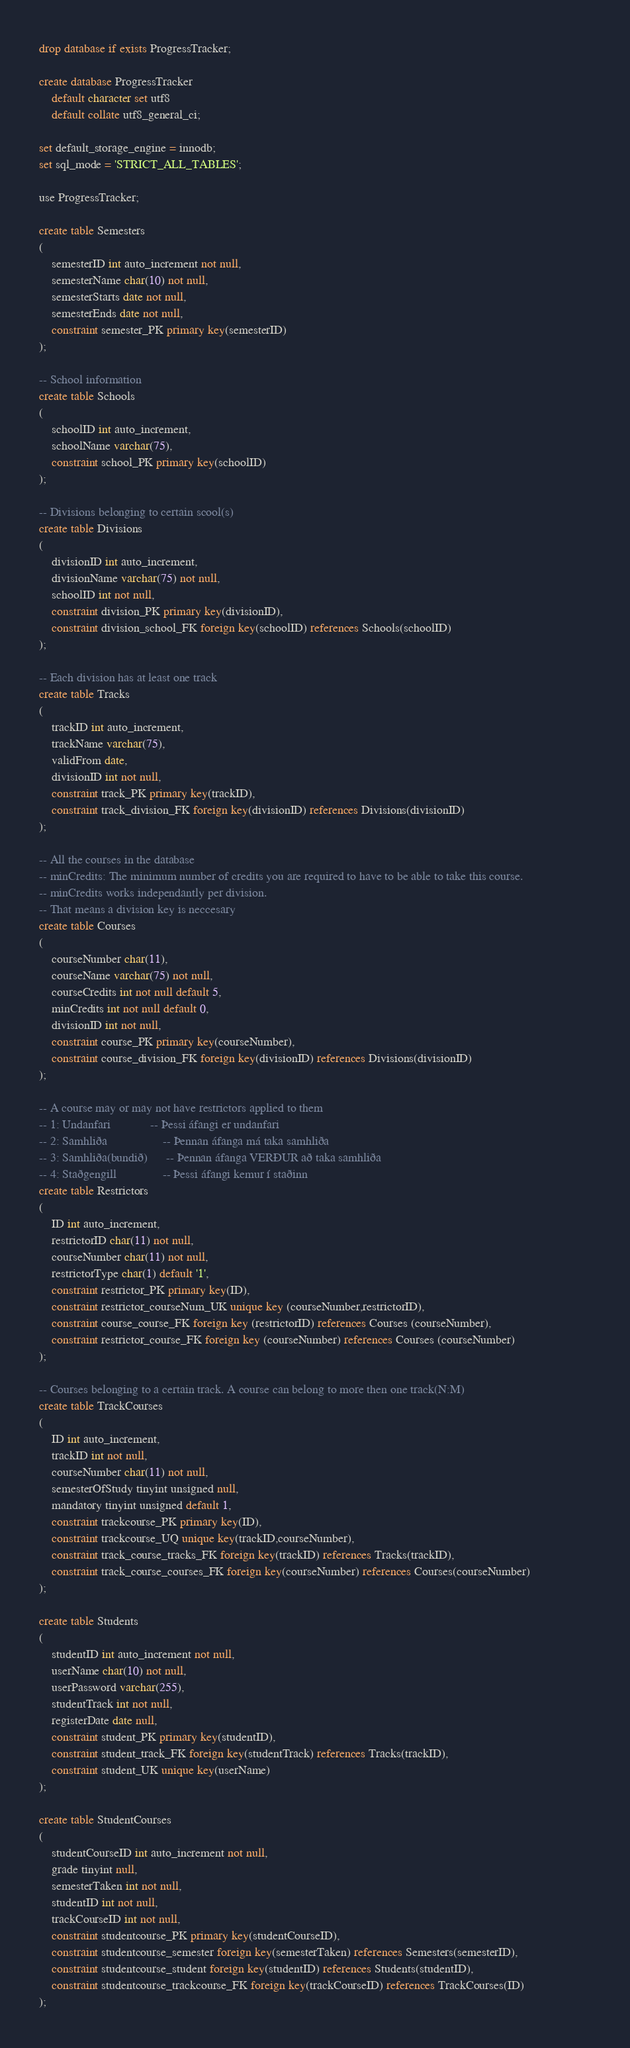Convert code to text. <code><loc_0><loc_0><loc_500><loc_500><_SQL_>drop database if exists ProgressTracker;

create database ProgressTracker
	default character set utf8
	default collate utf8_general_ci;

set default_storage_engine = innodb;
set sql_mode = 'STRICT_ALL_TABLES';

use ProgressTracker;

create table Semesters
(
	semesterID int auto_increment not null,
    semesterName char(10) not null,
    semesterStarts date not null,
    semesterEnds date not null,
    constraint semester_PK primary key(semesterID)
);

-- School information
create table Schools
(
	schoolID int auto_increment,
    schoolName varchar(75),
    constraint school_PK primary key(schoolID)
);

-- Divisions belonging to certain scool(s)
create table Divisions
(
	divisionID int auto_increment,
    divisionName varchar(75) not null,
    schoolID int not null,
    constraint division_PK primary key(divisionID),
    constraint division_school_FK foreign key(schoolID) references Schools(schoolID)
);

-- Each division has at least one track
create table Tracks
(
	trackID int auto_increment,
    trackName varchar(75),
    validFrom date,
    divisionID int not null,
    constraint track_PK primary key(trackID),
    constraint track_division_FK foreign key(divisionID) references Divisions(divisionID)
);

-- All the courses in the database
-- minCredits: The minimum number of credits you are required to have to be able to take this course.
-- minCredits works independantly per division.
-- That means a division key is neccesary
create table Courses 
(
	courseNumber char(11),
	courseName varchar(75) not null,
	courseCredits int not null default 5,
    minCredits int not null default 0,
	divisionID int not null,
	constraint course_PK primary key(courseNumber),
	constraint course_division_FK foreign key(divisionID) references Divisions(divisionID)
);

-- A course may or may not have restrictors applied to them
-- 1: Undanfari				-- Þessi áfangi er undanfari 
-- 2: Samhliða					-- Þennan áfanga má taka samhliða
-- 3: Samhliða(bundið)		-- Þennan áfanga VERÐUR að taka samhliða
-- 4: Staðgengill				-- Þessi áfangi kemur í staðinn
create table Restrictors 
(
	ID int auto_increment,
	restrictorID char(11) not null,
    courseNumber char(11) not null,
	restrictorType char(1) default '1',
	constraint restrictor_PK primary key(ID),
	constraint restrictor_courseNum_UK unique key (courseNumber,restrictorID),
	constraint course_course_FK foreign key (restrictorID) references Courses (courseNumber),
	constraint restrictor_course_FK foreign key (courseNumber) references Courses (courseNumber)
);

-- Courses belonging to a certain track. A course can belong to more then one track(N:M)
create table TrackCourses
(
	ID int auto_increment,
	trackID int not null,
    courseNumber char(11) not null,
    semesterOfStudy tinyint unsigned null,
    mandatory tinyint unsigned default 1,
	constraint trackcourse_PK primary key(ID),
    constraint trackcourse_UQ unique key(trackID,courseNumber),
    constraint track_course_tracks_FK foreign key(trackID) references Tracks(trackID),
    constraint track_course_courses_FK foreign key(courseNumber) references Courses(courseNumber)
);

create table Students
(
	studentID int auto_increment not null,                                                                                                                   
    userName char(10) not null,
    userPassword varchar(255),
    studentTrack int not null,
    registerDate date null,
    constraint student_PK primary key(studentID),
    constraint student_track_FK foreign key(studentTrack) references Tracks(trackID),
    constraint student_UK unique key(userName)
);

create table StudentCourses
(
	studentCourseID int auto_increment not null,
    grade tinyint null,
    semesterTaken int not null,
    studentID int not null,
    trackCourseID int not null,
    constraint studentcourse_PK primary key(studentCourseID),
    constraint studentcourse_semester foreign key(semesterTaken) references Semesters(semesterID),
    constraint studentcourse_student foreign key(studentID) references Students(studentID),
    constraint studentcourse_trackcourse_FK foreign key(trackCourseID) references TrackCourses(ID)
);</code> 